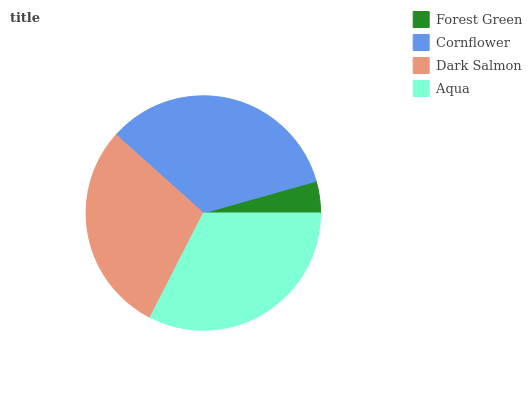Is Forest Green the minimum?
Answer yes or no. Yes. Is Cornflower the maximum?
Answer yes or no. Yes. Is Dark Salmon the minimum?
Answer yes or no. No. Is Dark Salmon the maximum?
Answer yes or no. No. Is Cornflower greater than Dark Salmon?
Answer yes or no. Yes. Is Dark Salmon less than Cornflower?
Answer yes or no. Yes. Is Dark Salmon greater than Cornflower?
Answer yes or no. No. Is Cornflower less than Dark Salmon?
Answer yes or no. No. Is Aqua the high median?
Answer yes or no. Yes. Is Dark Salmon the low median?
Answer yes or no. Yes. Is Forest Green the high median?
Answer yes or no. No. Is Aqua the low median?
Answer yes or no. No. 